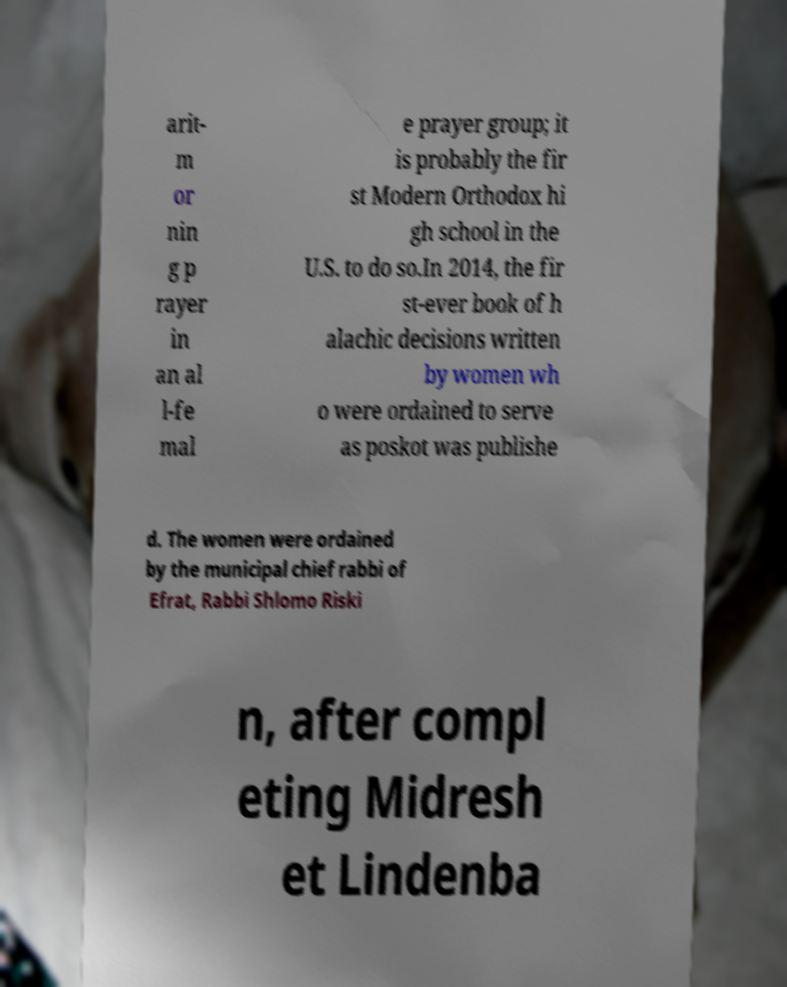For documentation purposes, I need the text within this image transcribed. Could you provide that? arit- m or nin g p rayer in an al l-fe mal e prayer group; it is probably the fir st Modern Orthodox hi gh school in the U.S. to do so.In 2014, the fir st-ever book of h alachic decisions written by women wh o were ordained to serve as poskot was publishe d. The women were ordained by the municipal chief rabbi of Efrat, Rabbi Shlomo Riski n, after compl eting Midresh et Lindenba 